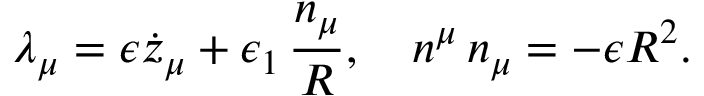Convert formula to latex. <formula><loc_0><loc_0><loc_500><loc_500>\lambda _ { \mu } = \epsilon \dot { z } _ { \mu } + \epsilon _ { 1 } \, { \frac { n _ { \mu } } { R } } , n ^ { \mu } \, n _ { \mu } = - \epsilon R ^ { 2 } .</formula> 